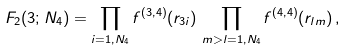<formula> <loc_0><loc_0><loc_500><loc_500>F _ { 2 } ( 3 ; N _ { 4 } ) = \prod _ { i = 1 , N _ { 4 } } f ^ { ( 3 , 4 ) } ( r _ { 3 i } ) \, \prod _ { m > l = 1 , N _ { 4 } } f ^ { ( 4 , 4 ) } ( r _ { l m } ) \, ,</formula> 